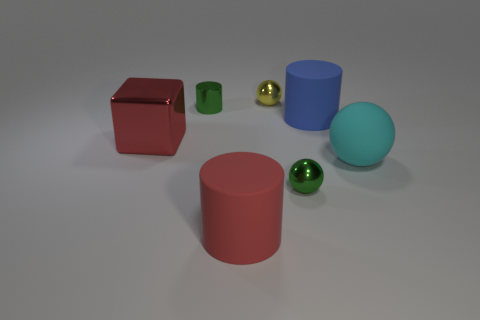Add 1 large gray rubber balls. How many objects exist? 8 Subtract all blue matte cylinders. How many cylinders are left? 2 Subtract all cylinders. How many objects are left? 4 Subtract all yellow spheres. How many spheres are left? 2 Subtract 0 brown cylinders. How many objects are left? 7 Subtract 1 balls. How many balls are left? 2 Subtract all green cubes. Subtract all brown cylinders. How many cubes are left? 1 Subtract all cyan balls. How many brown cubes are left? 0 Subtract all small yellow spheres. Subtract all brown matte cubes. How many objects are left? 6 Add 5 large metallic objects. How many large metallic objects are left? 6 